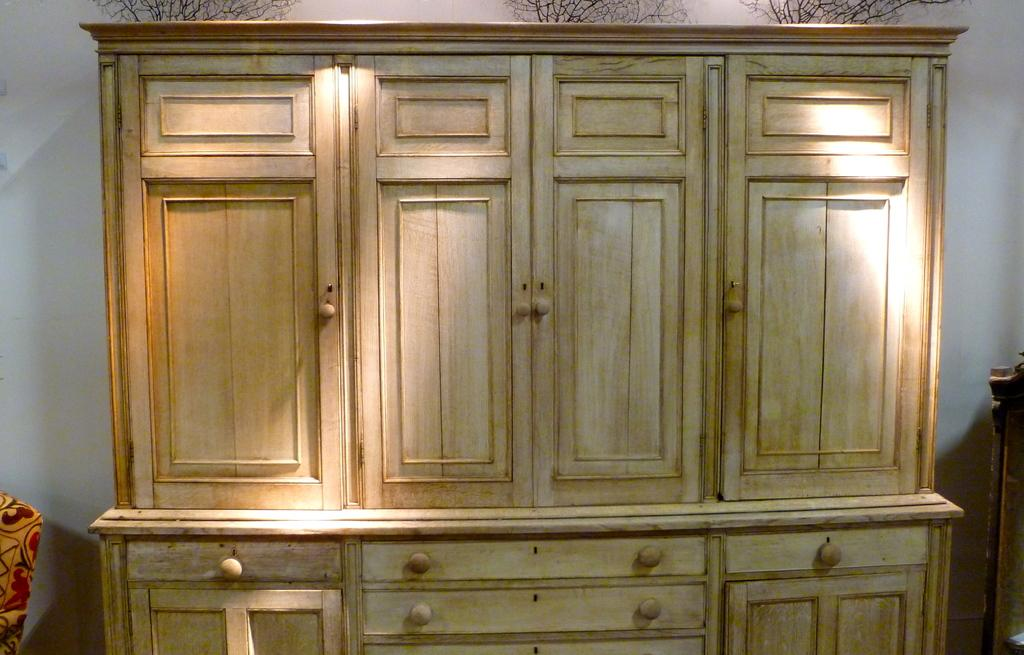What type of furniture is in the image? There is a cupboard in the image. What color is the cupboard? The cupboard is cream-colored. What can be seen to the left of the cupboard? There is a yellow and red cloth to the left of the cupboard. What is visible in the background of the image? The sky is visible in the background of the image, and it is white. What advertisement is being displayed on the cupboard in the image? There is no advertisement displayed on the cupboard in the image. Can you see a fly on the yellow and red cloth in the image? There is no fly visible on the yellow and red cloth in the image. 